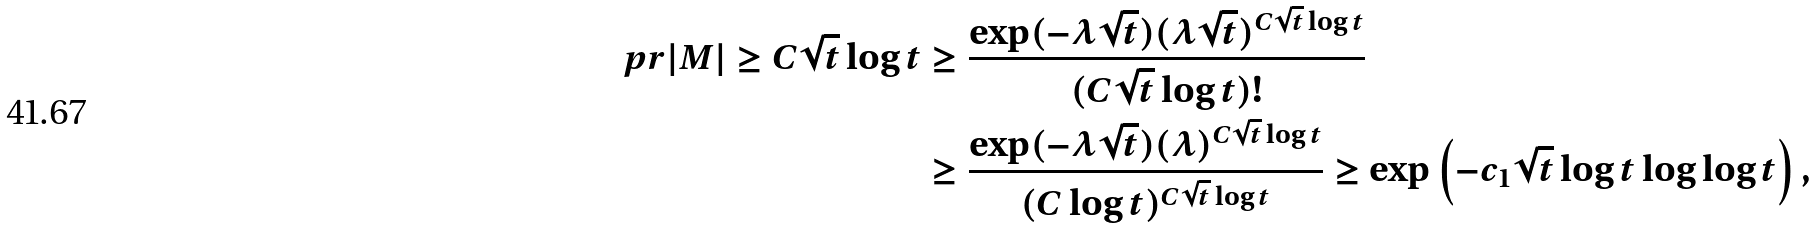<formula> <loc_0><loc_0><loc_500><loc_500>\ p r { | M | \geq C \sqrt { t } \log t } & \geq \frac { \exp ( - \lambda \sqrt { t } ) ( \lambda \sqrt { t } ) ^ { C \sqrt { t } \log t } } { ( C \sqrt { t } \log t ) ! } \\ & \geq \frac { \exp ( - \lambda \sqrt { t } ) ( \lambda ) ^ { C \sqrt { t } \log t } } { ( C \log t ) ^ { C \sqrt { t } \log t } } \geq \exp \left ( - c _ { 1 } \sqrt { t } \log t \log \log t \right ) ,</formula> 